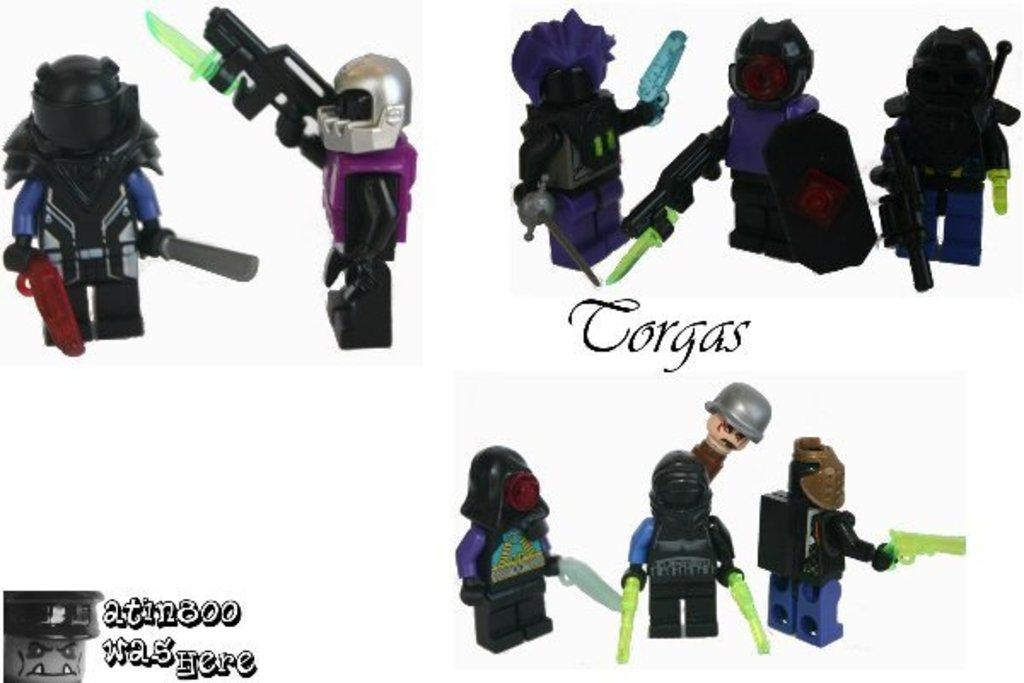What type of images can be seen in the picture? There are pictures of toys in the image. What else is present in the image besides the toy pictures? There is text on a paper in the image. How many pizzas are shown in the image? There are no pizzas present in the image; it features pictures of toys and text on a paper. What type of thing is shown interacting with the toys in the image? There is no thing shown interacting with the toys in the image; only the pictures of toys and text on a paper are present. 